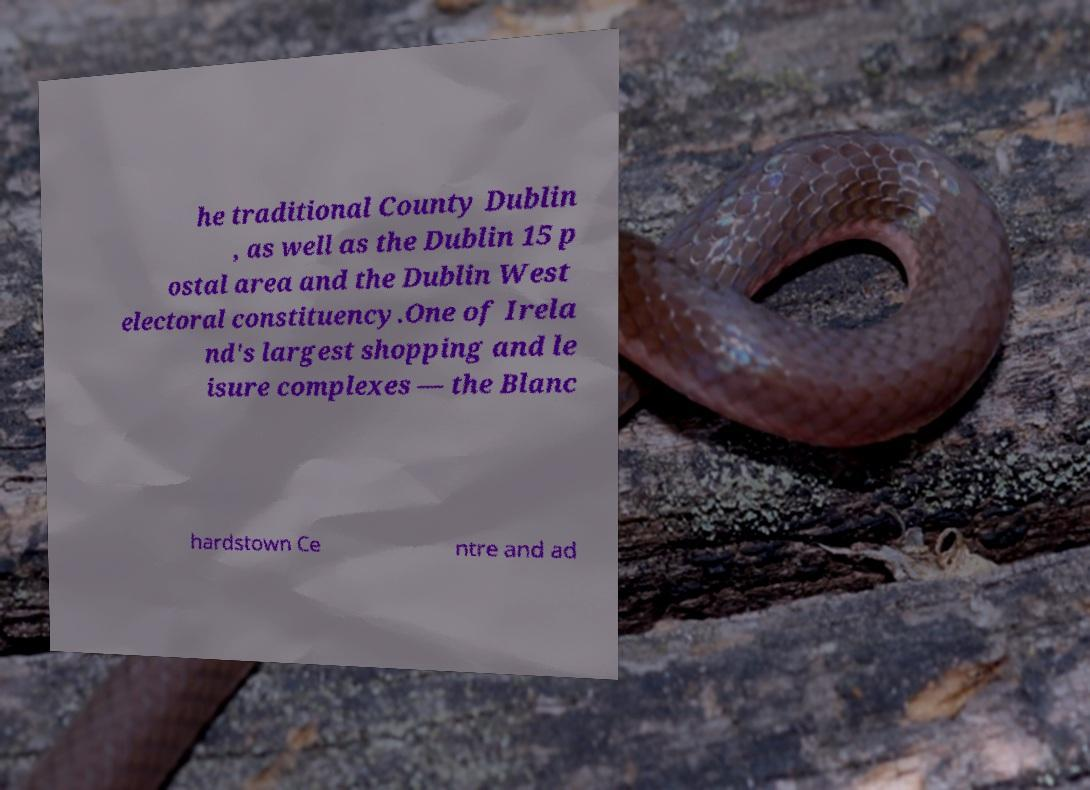Can you read and provide the text displayed in the image?This photo seems to have some interesting text. Can you extract and type it out for me? he traditional County Dublin , as well as the Dublin 15 p ostal area and the Dublin West electoral constituency.One of Irela nd's largest shopping and le isure complexes — the Blanc hardstown Ce ntre and ad 